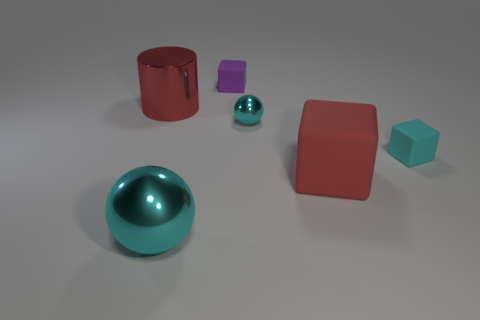Add 1 big cylinders. How many objects exist? 7 Subtract all cylinders. How many objects are left? 5 Subtract all large cyan metal cylinders. Subtract all tiny shiny spheres. How many objects are left? 5 Add 2 balls. How many balls are left? 4 Add 2 tiny cyan blocks. How many tiny cyan blocks exist? 3 Subtract 0 yellow blocks. How many objects are left? 6 